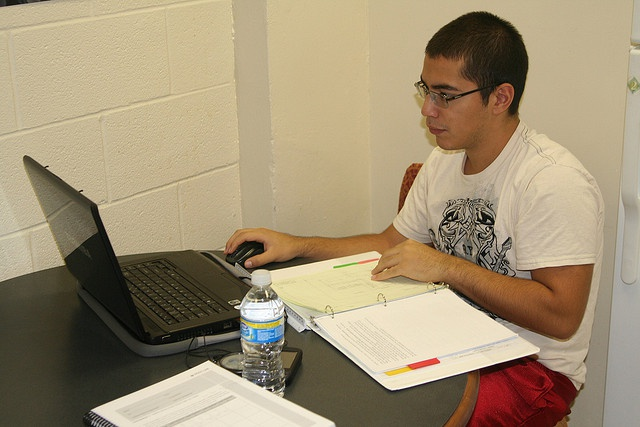Describe the objects in this image and their specific colors. I can see people in black, brown, and tan tones, book in black, beige, khaki, darkgray, and tan tones, laptop in black, gray, and darkgreen tones, bottle in black, gray, white, darkgray, and beige tones, and mouse in black, gray, brown, and tan tones in this image. 